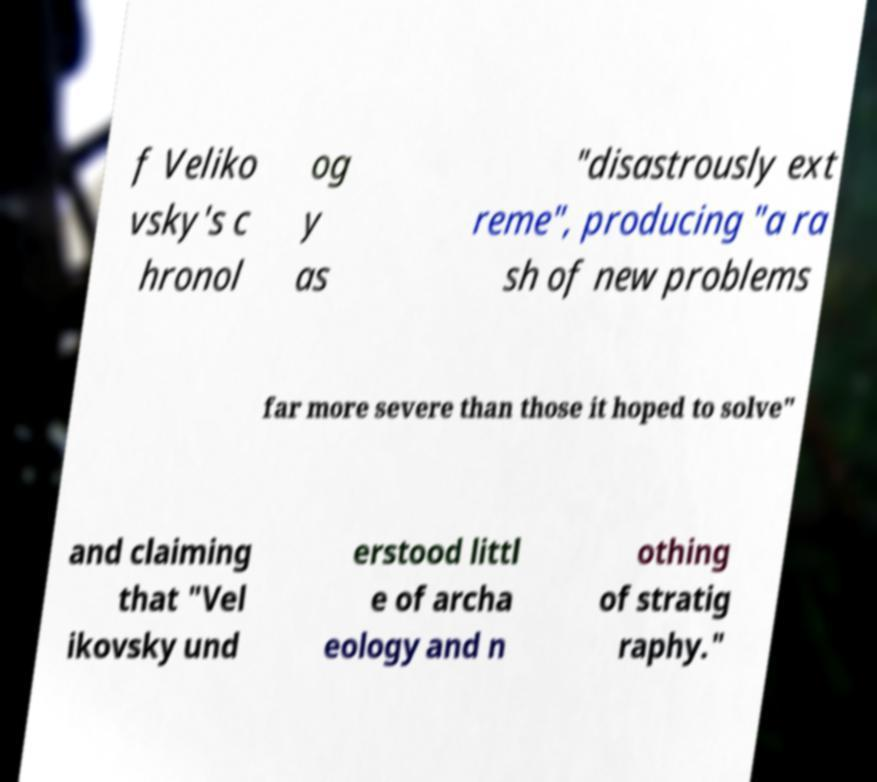Can you accurately transcribe the text from the provided image for me? f Veliko vsky's c hronol og y as "disastrously ext reme", producing "a ra sh of new problems far more severe than those it hoped to solve" and claiming that "Vel ikovsky und erstood littl e of archa eology and n othing of stratig raphy." 